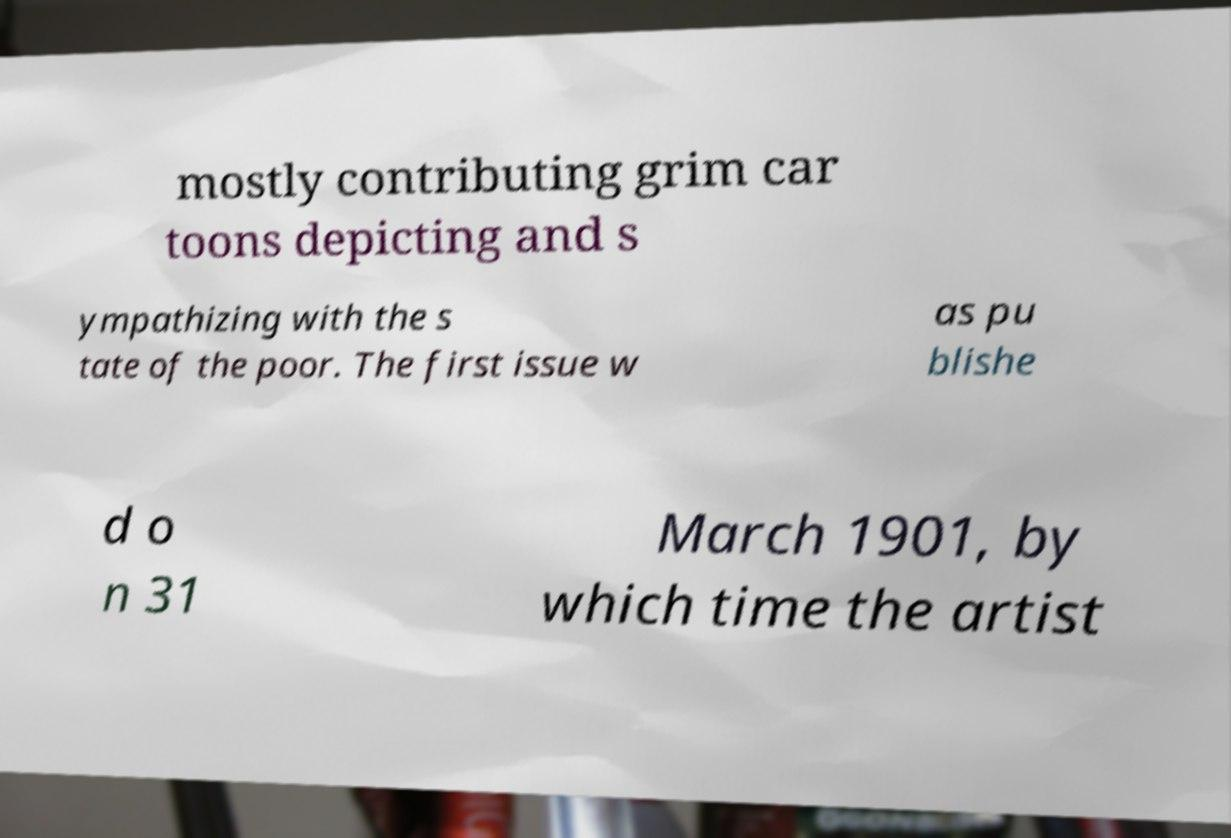I need the written content from this picture converted into text. Can you do that? mostly contributing grim car toons depicting and s ympathizing with the s tate of the poor. The first issue w as pu blishe d o n 31 March 1901, by which time the artist 